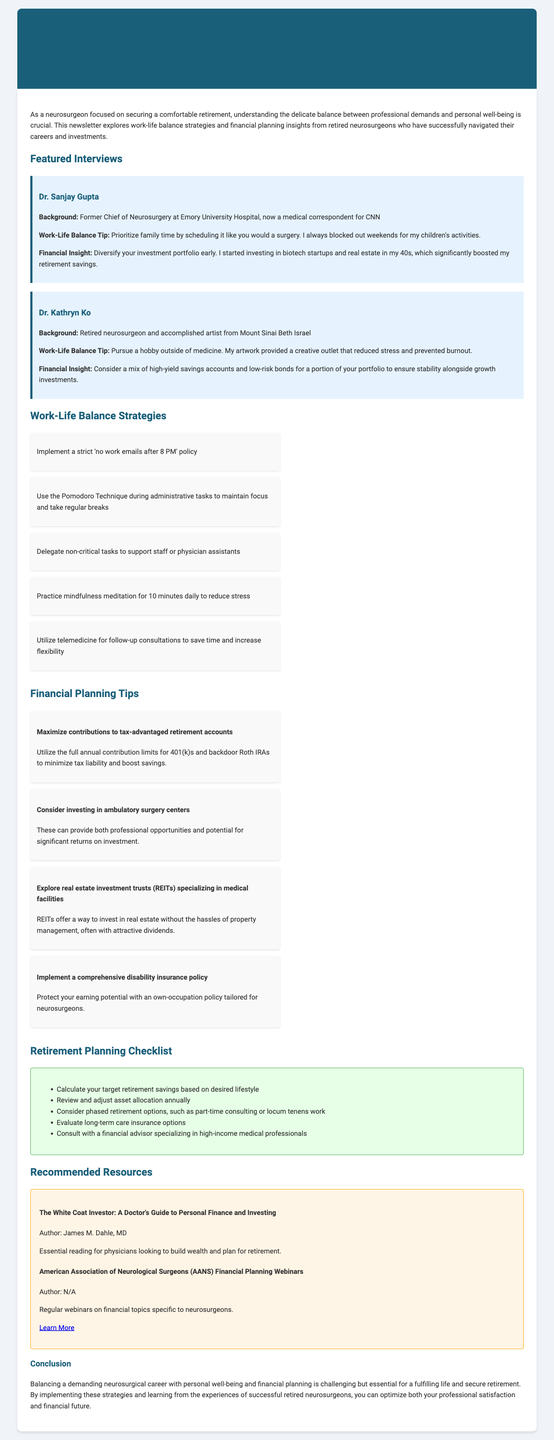what is the title of the newsletter? The title is provided in the document as the newsletter's title.
Answer: Balancing the Scalpel and the Ledger: Insights for Neurosurgeons' Work-Life Balance and Financial Success who is the former Chief of Neurosurgery at Emory University Hospital? This information is found in the featured interviews section, where the background of Dr. Sanjay Gupta is mentioned.
Answer: Dr. Sanjay Gupta what financial insight did Dr. Kathryn Ko share? This insight is included in Dr. Kathryn Ko's interview regarding financial planning.
Answer: Consider a mix of high-yield savings accounts and low-risk bonds for a portion of your portfolio to ensure stability alongside growth investments how many work-life balance strategies are listed? The number of strategies can be determined by counting the strategies in the provided list.
Answer: Five what is one recommended resource mentioned in the newsletter? This resource is included in the recommended resources section, where essential readings are listed.
Answer: The White Coat Investor: A Doctor's Guide to Personal Finance and Investing what percentage of retirement savings does the document suggest maximizing contributions? This is indicated within the financial planning tips emphasizing utilizing tax-advantaged retirement accounts.
Answer: Full annual contribution limits what is the background of Dr. Kathryn Ko? This information is available in Dr. Kathryn Ko's interview, highlighting her career before retirement.
Answer: Retired neurosurgeon and accomplished artist from Mount Sinai Beth Israel what specific insurance policy is recommended for neurosurgeons? The document includes this recommendation within the financial planning tips focused on protecting earning potential.
Answer: Comprehensive disability insurance policy 